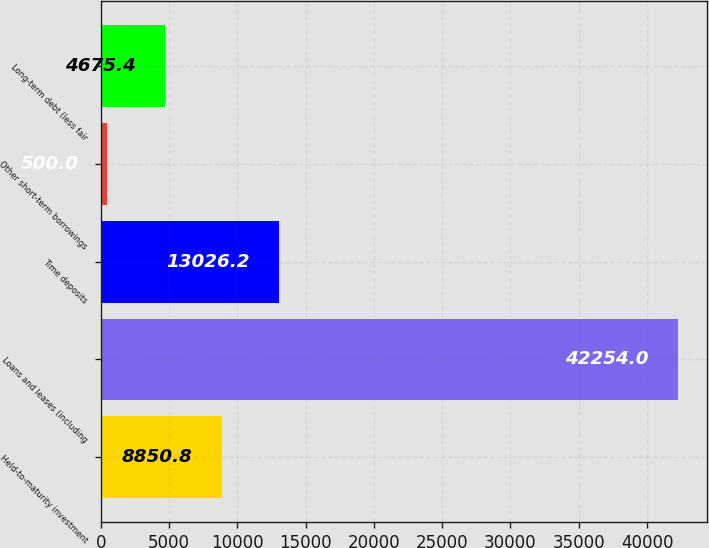<chart> <loc_0><loc_0><loc_500><loc_500><bar_chart><fcel>Held-to-maturity investment<fcel>Loans and leases (including<fcel>Time deposits<fcel>Other short-term borrowings<fcel>Long-term debt (less fair<nl><fcel>8850.8<fcel>42254<fcel>13026.2<fcel>500<fcel>4675.4<nl></chart> 